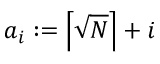<formula> <loc_0><loc_0><loc_500><loc_500>a _ { i } \colon = \left \lceil { \sqrt { N } } \right \rceil + i</formula> 